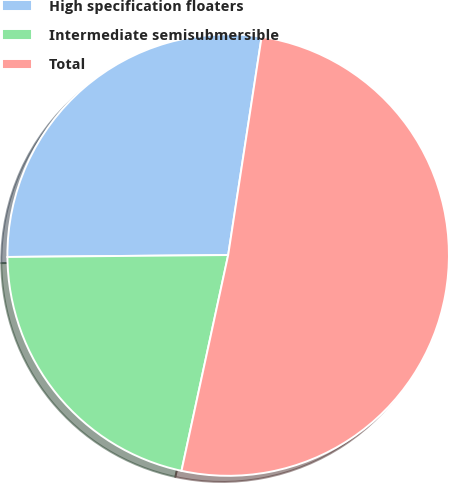Convert chart. <chart><loc_0><loc_0><loc_500><loc_500><pie_chart><fcel>High specification floaters<fcel>Intermediate semisubmersible<fcel>Total<nl><fcel>27.56%<fcel>21.47%<fcel>50.97%<nl></chart> 